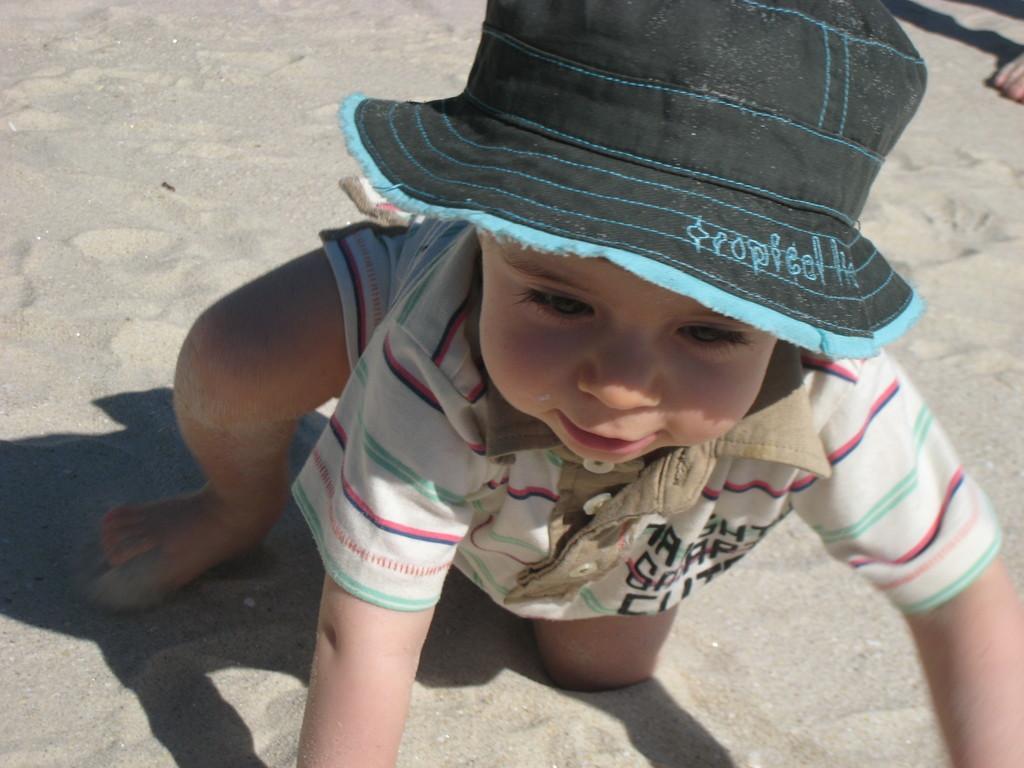Please provide a concise description of this image. In this picture I can see a boy wore a cap on this head and I can see sand on the ground and a human leg. 